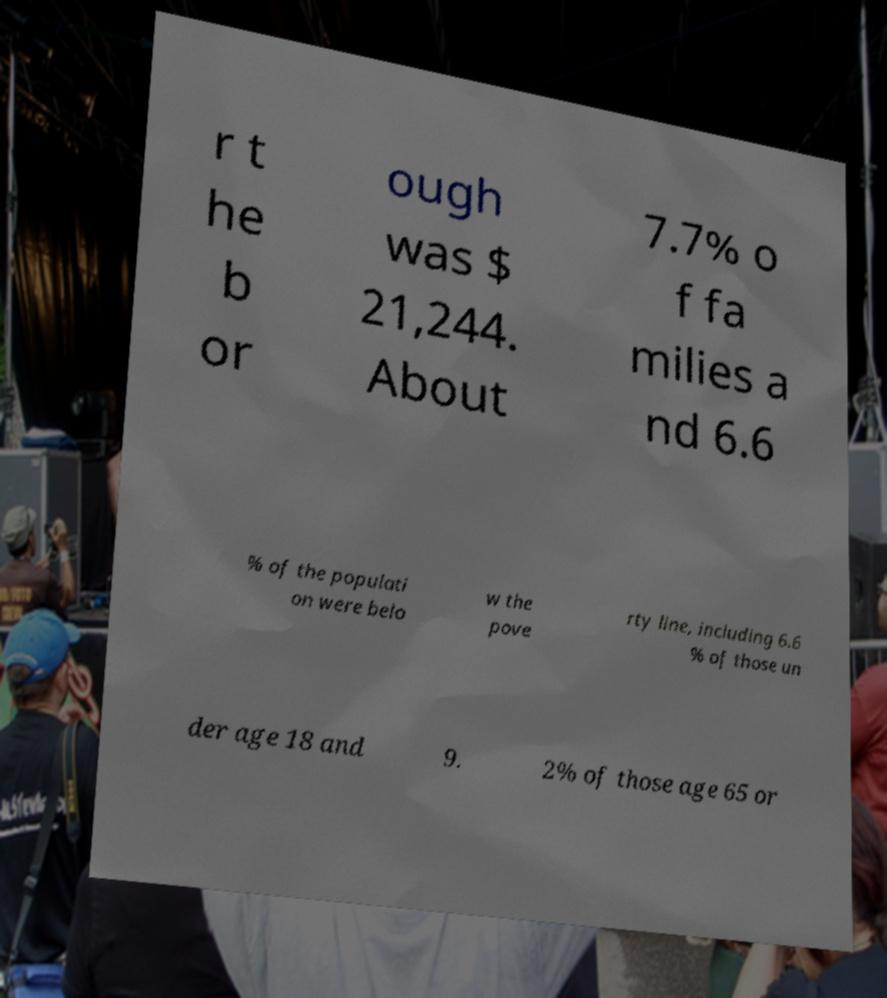Please read and relay the text visible in this image. What does it say? r t he b or ough was $ 21,244. About 7.7% o f fa milies a nd 6.6 % of the populati on were belo w the pove rty line, including 6.6 % of those un der age 18 and 9. 2% of those age 65 or 